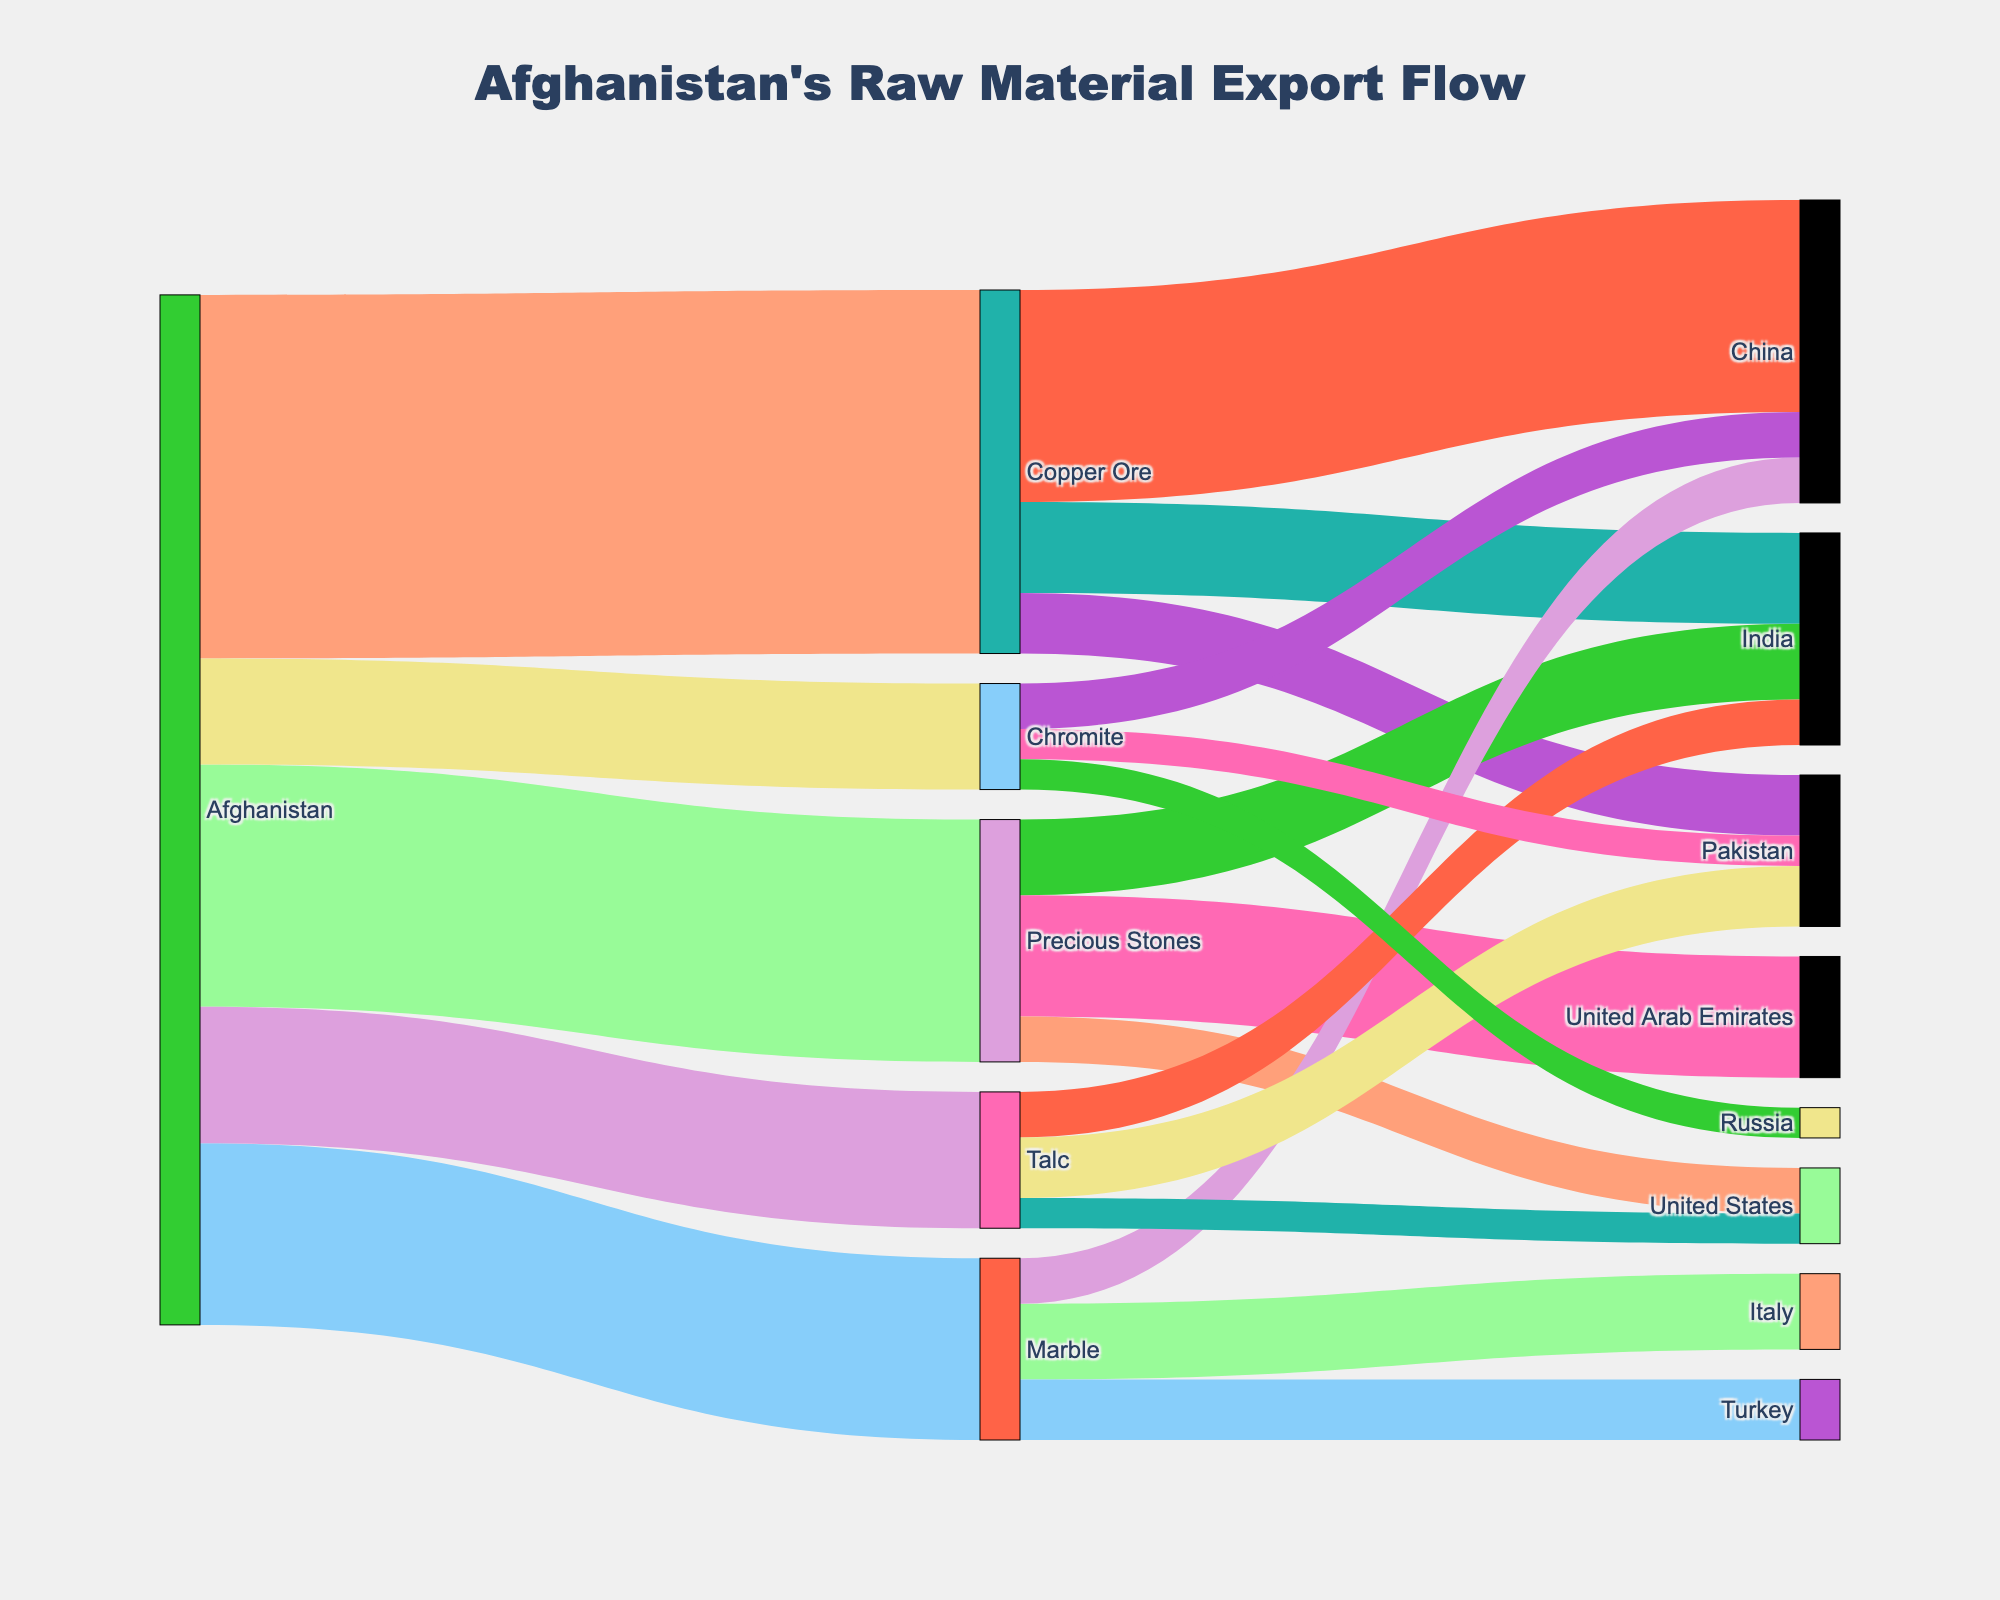Who is the largest importer of Copper Ore from Afghanistan? Examine the sinks connected to Copper Ore; China has the highest value at 700.
Answer: China How much total value of Marble does Afghanistan export? Sum the values for all the destinations of Marble: Italy (250) + Turkey (200) + China (150). 250 + 200 + 150 = 600.
Answer: 600 Which commodity has the lowest export value from Afghanistan? Compare the initial values connected to Afghanistan. Chromite has the lowest initial value of 350.
Answer: Chromite Between Talc and Chromite, which has a higher total export value? Talc (450) compared to Chromite (350); thus Talc is higher.
Answer: Talc What is the combined export value of Afghanistan's Copper Ore to India and Pakistan? Add the values for Copper Ore to India (300) and Pakistan (200). 300 + 200 = 500.
Answer: 500 Which country imports the most diverse range of commodities from Afghanistan? UAE imports Precious Stones, Italy Marble, China Copper Ore and Marble, India Copper Ore, Precious Stones, and Russia Chromite. Therefore, India imports three types.
Answer: India Which commodity has the highest number of destination countries? Copper Ore has three countries: China, India, and Pakistan.
Answer: Copper Ore Compare the export values of Marble to Italy and Turkey. Which is higher? Look at the values connected to Marble for Italy (250) and Turkey (200). Thus, Italy is higher.
Answer: Italy What is the total value of Afghanistan’s exports to the United States? Sum the values of all commodities exported to the United States: Precious Stones (150) + Talc (100). 150 + 100 = 250.
Answer: 250 How much more Copper Ore is exported to China compared to Pakistan? Subtract the value of Copper Ore to Pakistan (200) from the value to China (700). 700 - 200 = 500.
Answer: 500 